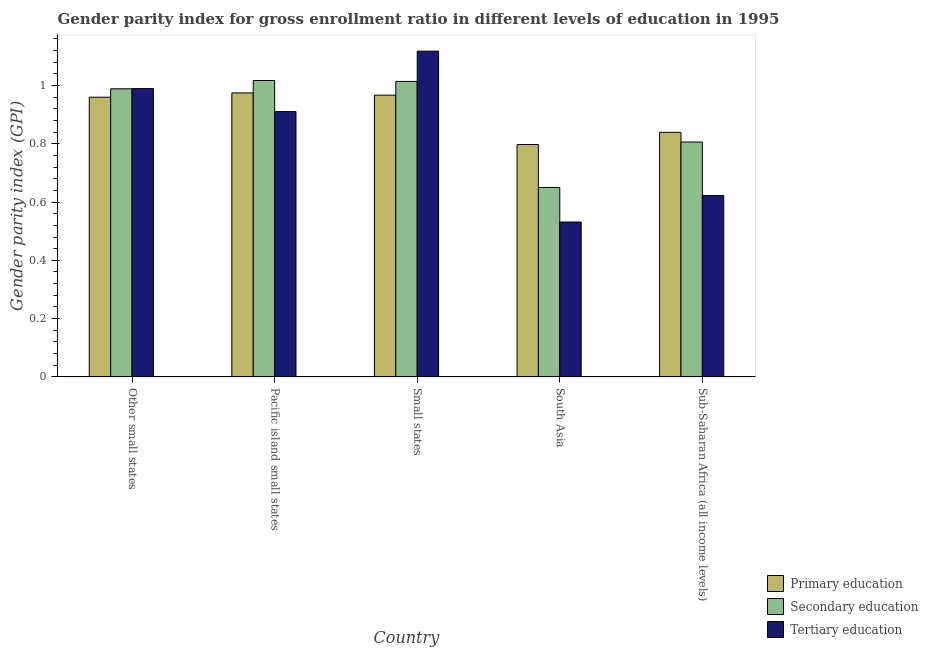How many different coloured bars are there?
Ensure brevity in your answer.  3. How many groups of bars are there?
Your answer should be compact. 5. Are the number of bars per tick equal to the number of legend labels?
Offer a terse response. Yes. In how many cases, is the number of bars for a given country not equal to the number of legend labels?
Your answer should be very brief. 0. What is the gender parity index in secondary education in Pacific island small states?
Your answer should be compact. 1.02. Across all countries, what is the maximum gender parity index in secondary education?
Your answer should be very brief. 1.02. Across all countries, what is the minimum gender parity index in secondary education?
Ensure brevity in your answer.  0.65. In which country was the gender parity index in tertiary education maximum?
Your response must be concise. Small states. In which country was the gender parity index in secondary education minimum?
Your response must be concise. South Asia. What is the total gender parity index in primary education in the graph?
Provide a succinct answer. 4.54. What is the difference between the gender parity index in secondary education in Small states and that in South Asia?
Ensure brevity in your answer.  0.36. What is the difference between the gender parity index in secondary education in Small states and the gender parity index in primary education in Pacific island small states?
Provide a short and direct response. 0.04. What is the average gender parity index in primary education per country?
Make the answer very short. 0.91. What is the difference between the gender parity index in tertiary education and gender parity index in primary education in Sub-Saharan Africa (all income levels)?
Offer a very short reply. -0.22. In how many countries, is the gender parity index in tertiary education greater than 1.08 ?
Your answer should be compact. 1. What is the ratio of the gender parity index in secondary education in Pacific island small states to that in Sub-Saharan Africa (all income levels)?
Provide a succinct answer. 1.26. Is the gender parity index in tertiary education in Other small states less than that in Small states?
Keep it short and to the point. Yes. What is the difference between the highest and the second highest gender parity index in primary education?
Your response must be concise. 0.01. What is the difference between the highest and the lowest gender parity index in secondary education?
Provide a short and direct response. 0.37. In how many countries, is the gender parity index in tertiary education greater than the average gender parity index in tertiary education taken over all countries?
Keep it short and to the point. 3. Is the sum of the gender parity index in tertiary education in Pacific island small states and Small states greater than the maximum gender parity index in secondary education across all countries?
Give a very brief answer. Yes. What does the 1st bar from the left in Small states represents?
Your answer should be compact. Primary education. What does the 1st bar from the right in Sub-Saharan Africa (all income levels) represents?
Offer a very short reply. Tertiary education. How many countries are there in the graph?
Your response must be concise. 5. What is the difference between two consecutive major ticks on the Y-axis?
Offer a terse response. 0.2. Are the values on the major ticks of Y-axis written in scientific E-notation?
Provide a succinct answer. No. Does the graph contain any zero values?
Your answer should be very brief. No. Does the graph contain grids?
Make the answer very short. No. Where does the legend appear in the graph?
Keep it short and to the point. Bottom right. How many legend labels are there?
Your answer should be compact. 3. What is the title of the graph?
Your answer should be very brief. Gender parity index for gross enrollment ratio in different levels of education in 1995. Does "Services" appear as one of the legend labels in the graph?
Ensure brevity in your answer.  No. What is the label or title of the X-axis?
Give a very brief answer. Country. What is the label or title of the Y-axis?
Your response must be concise. Gender parity index (GPI). What is the Gender parity index (GPI) of Primary education in Other small states?
Give a very brief answer. 0.96. What is the Gender parity index (GPI) in Secondary education in Other small states?
Your answer should be very brief. 0.99. What is the Gender parity index (GPI) in Tertiary education in Other small states?
Ensure brevity in your answer.  0.99. What is the Gender parity index (GPI) of Primary education in Pacific island small states?
Ensure brevity in your answer.  0.97. What is the Gender parity index (GPI) of Secondary education in Pacific island small states?
Offer a terse response. 1.02. What is the Gender parity index (GPI) in Tertiary education in Pacific island small states?
Ensure brevity in your answer.  0.91. What is the Gender parity index (GPI) in Primary education in Small states?
Offer a very short reply. 0.97. What is the Gender parity index (GPI) in Secondary education in Small states?
Offer a very short reply. 1.01. What is the Gender parity index (GPI) of Tertiary education in Small states?
Offer a terse response. 1.12. What is the Gender parity index (GPI) of Primary education in South Asia?
Keep it short and to the point. 0.8. What is the Gender parity index (GPI) in Secondary education in South Asia?
Give a very brief answer. 0.65. What is the Gender parity index (GPI) in Tertiary education in South Asia?
Provide a short and direct response. 0.53. What is the Gender parity index (GPI) in Primary education in Sub-Saharan Africa (all income levels)?
Your response must be concise. 0.84. What is the Gender parity index (GPI) in Secondary education in Sub-Saharan Africa (all income levels)?
Your answer should be compact. 0.81. What is the Gender parity index (GPI) of Tertiary education in Sub-Saharan Africa (all income levels)?
Offer a terse response. 0.62. Across all countries, what is the maximum Gender parity index (GPI) in Primary education?
Give a very brief answer. 0.97. Across all countries, what is the maximum Gender parity index (GPI) in Secondary education?
Keep it short and to the point. 1.02. Across all countries, what is the maximum Gender parity index (GPI) in Tertiary education?
Your response must be concise. 1.12. Across all countries, what is the minimum Gender parity index (GPI) in Primary education?
Your answer should be very brief. 0.8. Across all countries, what is the minimum Gender parity index (GPI) of Secondary education?
Provide a succinct answer. 0.65. Across all countries, what is the minimum Gender parity index (GPI) in Tertiary education?
Offer a terse response. 0.53. What is the total Gender parity index (GPI) of Primary education in the graph?
Provide a succinct answer. 4.54. What is the total Gender parity index (GPI) in Secondary education in the graph?
Offer a very short reply. 4.48. What is the total Gender parity index (GPI) of Tertiary education in the graph?
Offer a terse response. 4.17. What is the difference between the Gender parity index (GPI) in Primary education in Other small states and that in Pacific island small states?
Offer a terse response. -0.01. What is the difference between the Gender parity index (GPI) in Secondary education in Other small states and that in Pacific island small states?
Your answer should be very brief. -0.03. What is the difference between the Gender parity index (GPI) of Tertiary education in Other small states and that in Pacific island small states?
Your answer should be very brief. 0.08. What is the difference between the Gender parity index (GPI) of Primary education in Other small states and that in Small states?
Make the answer very short. -0.01. What is the difference between the Gender parity index (GPI) of Secondary education in Other small states and that in Small states?
Provide a succinct answer. -0.03. What is the difference between the Gender parity index (GPI) of Tertiary education in Other small states and that in Small states?
Keep it short and to the point. -0.13. What is the difference between the Gender parity index (GPI) of Primary education in Other small states and that in South Asia?
Provide a short and direct response. 0.16. What is the difference between the Gender parity index (GPI) in Secondary education in Other small states and that in South Asia?
Provide a succinct answer. 0.34. What is the difference between the Gender parity index (GPI) in Tertiary education in Other small states and that in South Asia?
Keep it short and to the point. 0.46. What is the difference between the Gender parity index (GPI) of Primary education in Other small states and that in Sub-Saharan Africa (all income levels)?
Give a very brief answer. 0.12. What is the difference between the Gender parity index (GPI) of Secondary education in Other small states and that in Sub-Saharan Africa (all income levels)?
Ensure brevity in your answer.  0.18. What is the difference between the Gender parity index (GPI) of Tertiary education in Other small states and that in Sub-Saharan Africa (all income levels)?
Ensure brevity in your answer.  0.37. What is the difference between the Gender parity index (GPI) of Primary education in Pacific island small states and that in Small states?
Offer a very short reply. 0.01. What is the difference between the Gender parity index (GPI) of Secondary education in Pacific island small states and that in Small states?
Provide a short and direct response. 0. What is the difference between the Gender parity index (GPI) of Tertiary education in Pacific island small states and that in Small states?
Give a very brief answer. -0.21. What is the difference between the Gender parity index (GPI) of Primary education in Pacific island small states and that in South Asia?
Give a very brief answer. 0.18. What is the difference between the Gender parity index (GPI) of Secondary education in Pacific island small states and that in South Asia?
Provide a short and direct response. 0.37. What is the difference between the Gender parity index (GPI) in Tertiary education in Pacific island small states and that in South Asia?
Offer a terse response. 0.38. What is the difference between the Gender parity index (GPI) in Primary education in Pacific island small states and that in Sub-Saharan Africa (all income levels)?
Make the answer very short. 0.14. What is the difference between the Gender parity index (GPI) in Secondary education in Pacific island small states and that in Sub-Saharan Africa (all income levels)?
Provide a succinct answer. 0.21. What is the difference between the Gender parity index (GPI) in Tertiary education in Pacific island small states and that in Sub-Saharan Africa (all income levels)?
Ensure brevity in your answer.  0.29. What is the difference between the Gender parity index (GPI) of Primary education in Small states and that in South Asia?
Keep it short and to the point. 0.17. What is the difference between the Gender parity index (GPI) in Secondary education in Small states and that in South Asia?
Ensure brevity in your answer.  0.36. What is the difference between the Gender parity index (GPI) in Tertiary education in Small states and that in South Asia?
Your answer should be compact. 0.59. What is the difference between the Gender parity index (GPI) in Primary education in Small states and that in Sub-Saharan Africa (all income levels)?
Your answer should be compact. 0.13. What is the difference between the Gender parity index (GPI) in Secondary education in Small states and that in Sub-Saharan Africa (all income levels)?
Your answer should be very brief. 0.21. What is the difference between the Gender parity index (GPI) of Tertiary education in Small states and that in Sub-Saharan Africa (all income levels)?
Make the answer very short. 0.5. What is the difference between the Gender parity index (GPI) of Primary education in South Asia and that in Sub-Saharan Africa (all income levels)?
Give a very brief answer. -0.04. What is the difference between the Gender parity index (GPI) of Secondary education in South Asia and that in Sub-Saharan Africa (all income levels)?
Offer a terse response. -0.16. What is the difference between the Gender parity index (GPI) in Tertiary education in South Asia and that in Sub-Saharan Africa (all income levels)?
Provide a short and direct response. -0.09. What is the difference between the Gender parity index (GPI) in Primary education in Other small states and the Gender parity index (GPI) in Secondary education in Pacific island small states?
Your answer should be very brief. -0.06. What is the difference between the Gender parity index (GPI) of Primary education in Other small states and the Gender parity index (GPI) of Tertiary education in Pacific island small states?
Offer a very short reply. 0.05. What is the difference between the Gender parity index (GPI) of Secondary education in Other small states and the Gender parity index (GPI) of Tertiary education in Pacific island small states?
Provide a succinct answer. 0.08. What is the difference between the Gender parity index (GPI) of Primary education in Other small states and the Gender parity index (GPI) of Secondary education in Small states?
Your answer should be very brief. -0.05. What is the difference between the Gender parity index (GPI) of Primary education in Other small states and the Gender parity index (GPI) of Tertiary education in Small states?
Make the answer very short. -0.16. What is the difference between the Gender parity index (GPI) of Secondary education in Other small states and the Gender parity index (GPI) of Tertiary education in Small states?
Make the answer very short. -0.13. What is the difference between the Gender parity index (GPI) of Primary education in Other small states and the Gender parity index (GPI) of Secondary education in South Asia?
Your answer should be very brief. 0.31. What is the difference between the Gender parity index (GPI) of Primary education in Other small states and the Gender parity index (GPI) of Tertiary education in South Asia?
Offer a very short reply. 0.43. What is the difference between the Gender parity index (GPI) in Secondary education in Other small states and the Gender parity index (GPI) in Tertiary education in South Asia?
Give a very brief answer. 0.46. What is the difference between the Gender parity index (GPI) of Primary education in Other small states and the Gender parity index (GPI) of Secondary education in Sub-Saharan Africa (all income levels)?
Offer a very short reply. 0.15. What is the difference between the Gender parity index (GPI) in Primary education in Other small states and the Gender parity index (GPI) in Tertiary education in Sub-Saharan Africa (all income levels)?
Your answer should be very brief. 0.34. What is the difference between the Gender parity index (GPI) in Secondary education in Other small states and the Gender parity index (GPI) in Tertiary education in Sub-Saharan Africa (all income levels)?
Make the answer very short. 0.37. What is the difference between the Gender parity index (GPI) in Primary education in Pacific island small states and the Gender parity index (GPI) in Secondary education in Small states?
Give a very brief answer. -0.04. What is the difference between the Gender parity index (GPI) of Primary education in Pacific island small states and the Gender parity index (GPI) of Tertiary education in Small states?
Keep it short and to the point. -0.14. What is the difference between the Gender parity index (GPI) in Secondary education in Pacific island small states and the Gender parity index (GPI) in Tertiary education in Small states?
Provide a short and direct response. -0.1. What is the difference between the Gender parity index (GPI) in Primary education in Pacific island small states and the Gender parity index (GPI) in Secondary education in South Asia?
Your answer should be compact. 0.32. What is the difference between the Gender parity index (GPI) of Primary education in Pacific island small states and the Gender parity index (GPI) of Tertiary education in South Asia?
Your response must be concise. 0.44. What is the difference between the Gender parity index (GPI) in Secondary education in Pacific island small states and the Gender parity index (GPI) in Tertiary education in South Asia?
Provide a short and direct response. 0.49. What is the difference between the Gender parity index (GPI) in Primary education in Pacific island small states and the Gender parity index (GPI) in Secondary education in Sub-Saharan Africa (all income levels)?
Provide a succinct answer. 0.17. What is the difference between the Gender parity index (GPI) of Primary education in Pacific island small states and the Gender parity index (GPI) of Tertiary education in Sub-Saharan Africa (all income levels)?
Keep it short and to the point. 0.35. What is the difference between the Gender parity index (GPI) in Secondary education in Pacific island small states and the Gender parity index (GPI) in Tertiary education in Sub-Saharan Africa (all income levels)?
Your answer should be compact. 0.39. What is the difference between the Gender parity index (GPI) of Primary education in Small states and the Gender parity index (GPI) of Secondary education in South Asia?
Your answer should be very brief. 0.32. What is the difference between the Gender parity index (GPI) of Primary education in Small states and the Gender parity index (GPI) of Tertiary education in South Asia?
Your answer should be compact. 0.44. What is the difference between the Gender parity index (GPI) of Secondary education in Small states and the Gender parity index (GPI) of Tertiary education in South Asia?
Make the answer very short. 0.48. What is the difference between the Gender parity index (GPI) of Primary education in Small states and the Gender parity index (GPI) of Secondary education in Sub-Saharan Africa (all income levels)?
Your answer should be compact. 0.16. What is the difference between the Gender parity index (GPI) of Primary education in Small states and the Gender parity index (GPI) of Tertiary education in Sub-Saharan Africa (all income levels)?
Your answer should be compact. 0.34. What is the difference between the Gender parity index (GPI) of Secondary education in Small states and the Gender parity index (GPI) of Tertiary education in Sub-Saharan Africa (all income levels)?
Your response must be concise. 0.39. What is the difference between the Gender parity index (GPI) of Primary education in South Asia and the Gender parity index (GPI) of Secondary education in Sub-Saharan Africa (all income levels)?
Make the answer very short. -0.01. What is the difference between the Gender parity index (GPI) in Primary education in South Asia and the Gender parity index (GPI) in Tertiary education in Sub-Saharan Africa (all income levels)?
Keep it short and to the point. 0.17. What is the difference between the Gender parity index (GPI) of Secondary education in South Asia and the Gender parity index (GPI) of Tertiary education in Sub-Saharan Africa (all income levels)?
Offer a terse response. 0.03. What is the average Gender parity index (GPI) in Primary education per country?
Offer a very short reply. 0.91. What is the average Gender parity index (GPI) of Secondary education per country?
Keep it short and to the point. 0.9. What is the average Gender parity index (GPI) of Tertiary education per country?
Ensure brevity in your answer.  0.83. What is the difference between the Gender parity index (GPI) of Primary education and Gender parity index (GPI) of Secondary education in Other small states?
Your response must be concise. -0.03. What is the difference between the Gender parity index (GPI) of Primary education and Gender parity index (GPI) of Tertiary education in Other small states?
Your answer should be compact. -0.03. What is the difference between the Gender parity index (GPI) in Secondary education and Gender parity index (GPI) in Tertiary education in Other small states?
Your answer should be very brief. -0. What is the difference between the Gender parity index (GPI) of Primary education and Gender parity index (GPI) of Secondary education in Pacific island small states?
Offer a terse response. -0.04. What is the difference between the Gender parity index (GPI) of Primary education and Gender parity index (GPI) of Tertiary education in Pacific island small states?
Provide a short and direct response. 0.06. What is the difference between the Gender parity index (GPI) in Secondary education and Gender parity index (GPI) in Tertiary education in Pacific island small states?
Provide a short and direct response. 0.11. What is the difference between the Gender parity index (GPI) in Primary education and Gender parity index (GPI) in Secondary education in Small states?
Give a very brief answer. -0.05. What is the difference between the Gender parity index (GPI) in Primary education and Gender parity index (GPI) in Tertiary education in Small states?
Provide a succinct answer. -0.15. What is the difference between the Gender parity index (GPI) in Secondary education and Gender parity index (GPI) in Tertiary education in Small states?
Keep it short and to the point. -0.1. What is the difference between the Gender parity index (GPI) of Primary education and Gender parity index (GPI) of Secondary education in South Asia?
Provide a short and direct response. 0.15. What is the difference between the Gender parity index (GPI) in Primary education and Gender parity index (GPI) in Tertiary education in South Asia?
Offer a terse response. 0.27. What is the difference between the Gender parity index (GPI) of Secondary education and Gender parity index (GPI) of Tertiary education in South Asia?
Offer a terse response. 0.12. What is the difference between the Gender parity index (GPI) of Primary education and Gender parity index (GPI) of Tertiary education in Sub-Saharan Africa (all income levels)?
Your answer should be compact. 0.22. What is the difference between the Gender parity index (GPI) of Secondary education and Gender parity index (GPI) of Tertiary education in Sub-Saharan Africa (all income levels)?
Provide a succinct answer. 0.18. What is the ratio of the Gender parity index (GPI) of Secondary education in Other small states to that in Pacific island small states?
Make the answer very short. 0.97. What is the ratio of the Gender parity index (GPI) of Tertiary education in Other small states to that in Pacific island small states?
Ensure brevity in your answer.  1.09. What is the ratio of the Gender parity index (GPI) of Secondary education in Other small states to that in Small states?
Make the answer very short. 0.98. What is the ratio of the Gender parity index (GPI) of Tertiary education in Other small states to that in Small states?
Give a very brief answer. 0.89. What is the ratio of the Gender parity index (GPI) in Primary education in Other small states to that in South Asia?
Make the answer very short. 1.2. What is the ratio of the Gender parity index (GPI) of Secondary education in Other small states to that in South Asia?
Provide a succinct answer. 1.52. What is the ratio of the Gender parity index (GPI) of Tertiary education in Other small states to that in South Asia?
Offer a terse response. 1.86. What is the ratio of the Gender parity index (GPI) in Primary education in Other small states to that in Sub-Saharan Africa (all income levels)?
Your response must be concise. 1.14. What is the ratio of the Gender parity index (GPI) of Secondary education in Other small states to that in Sub-Saharan Africa (all income levels)?
Make the answer very short. 1.23. What is the ratio of the Gender parity index (GPI) of Tertiary education in Other small states to that in Sub-Saharan Africa (all income levels)?
Offer a very short reply. 1.59. What is the ratio of the Gender parity index (GPI) in Secondary education in Pacific island small states to that in Small states?
Keep it short and to the point. 1. What is the ratio of the Gender parity index (GPI) in Tertiary education in Pacific island small states to that in Small states?
Make the answer very short. 0.81. What is the ratio of the Gender parity index (GPI) in Primary education in Pacific island small states to that in South Asia?
Make the answer very short. 1.22. What is the ratio of the Gender parity index (GPI) of Secondary education in Pacific island small states to that in South Asia?
Make the answer very short. 1.56. What is the ratio of the Gender parity index (GPI) of Tertiary education in Pacific island small states to that in South Asia?
Ensure brevity in your answer.  1.71. What is the ratio of the Gender parity index (GPI) of Primary education in Pacific island small states to that in Sub-Saharan Africa (all income levels)?
Give a very brief answer. 1.16. What is the ratio of the Gender parity index (GPI) of Secondary education in Pacific island small states to that in Sub-Saharan Africa (all income levels)?
Offer a terse response. 1.26. What is the ratio of the Gender parity index (GPI) in Tertiary education in Pacific island small states to that in Sub-Saharan Africa (all income levels)?
Provide a succinct answer. 1.46. What is the ratio of the Gender parity index (GPI) of Primary education in Small states to that in South Asia?
Ensure brevity in your answer.  1.21. What is the ratio of the Gender parity index (GPI) of Secondary education in Small states to that in South Asia?
Offer a very short reply. 1.56. What is the ratio of the Gender parity index (GPI) of Tertiary education in Small states to that in South Asia?
Your answer should be very brief. 2.1. What is the ratio of the Gender parity index (GPI) of Primary education in Small states to that in Sub-Saharan Africa (all income levels)?
Give a very brief answer. 1.15. What is the ratio of the Gender parity index (GPI) in Secondary education in Small states to that in Sub-Saharan Africa (all income levels)?
Ensure brevity in your answer.  1.26. What is the ratio of the Gender parity index (GPI) in Tertiary education in Small states to that in Sub-Saharan Africa (all income levels)?
Give a very brief answer. 1.8. What is the ratio of the Gender parity index (GPI) in Secondary education in South Asia to that in Sub-Saharan Africa (all income levels)?
Your answer should be compact. 0.81. What is the ratio of the Gender parity index (GPI) in Tertiary education in South Asia to that in Sub-Saharan Africa (all income levels)?
Provide a short and direct response. 0.85. What is the difference between the highest and the second highest Gender parity index (GPI) in Primary education?
Provide a short and direct response. 0.01. What is the difference between the highest and the second highest Gender parity index (GPI) of Secondary education?
Keep it short and to the point. 0. What is the difference between the highest and the second highest Gender parity index (GPI) of Tertiary education?
Ensure brevity in your answer.  0.13. What is the difference between the highest and the lowest Gender parity index (GPI) of Primary education?
Make the answer very short. 0.18. What is the difference between the highest and the lowest Gender parity index (GPI) in Secondary education?
Offer a very short reply. 0.37. What is the difference between the highest and the lowest Gender parity index (GPI) in Tertiary education?
Provide a succinct answer. 0.59. 